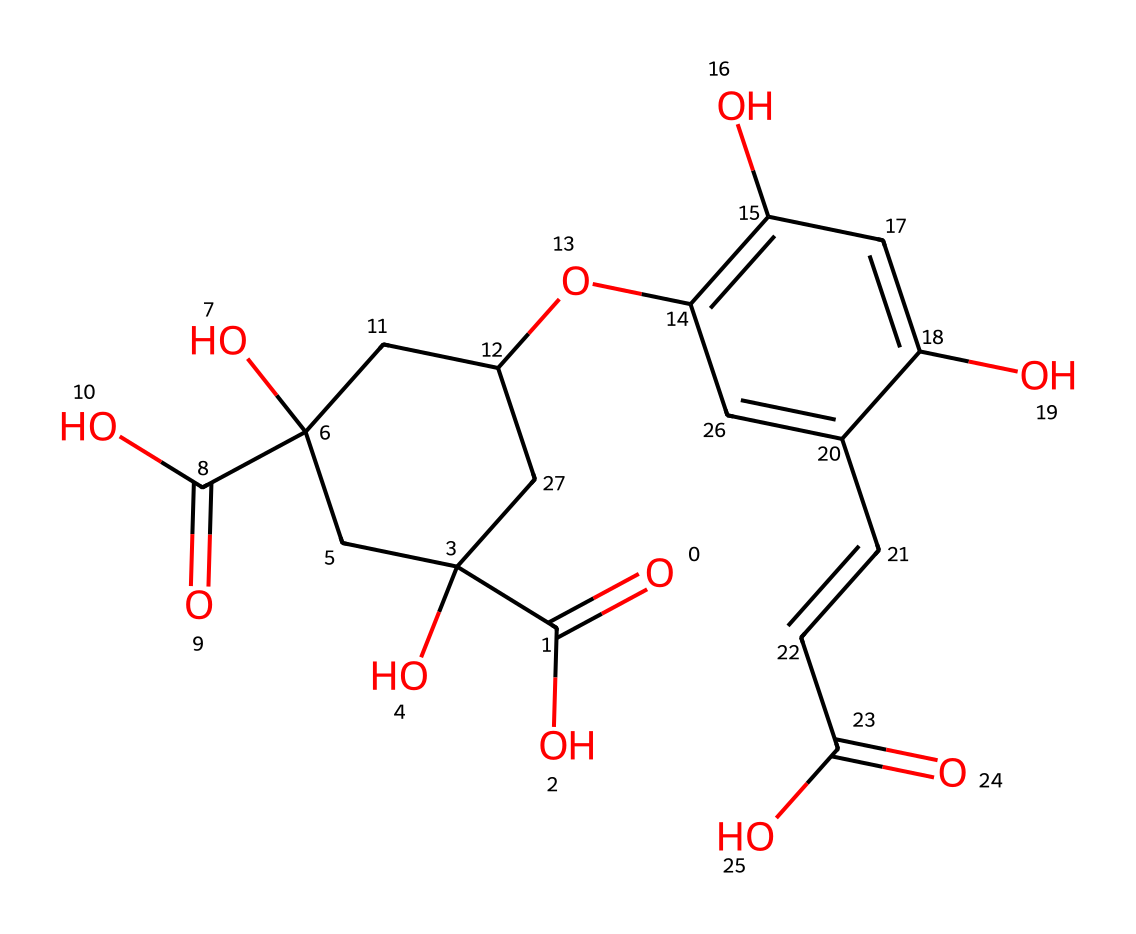What is the main functional group present in chlorogenic acid? Chlorogenic acid features multiple functional groups, the most prominent being the carboxylic acid groups (as indicated by the -COOH symbols in the structure).
Answer: carboxylic acid How many carbon atoms are in chlorogenic acid? By counting the carbon atoms represented in the SMILES format, there are 17 carbon atoms in total.
Answer: 17 What type of molecular structure does chlorogenic acid possess? The presence of multiple ring structures and hydroxyl groups indicates that chlorogenic acid has a polyphenolic structure.
Answer: polyphenolic How many hydroxyl groups are present in chlorogenic acid? Examination of the SMILES shows multiple -OH (hydroxyl) groups; specifically, there are 5 hydroxyl groups in the structure.
Answer: 5 What is the significance of the double bonds in chlorogenic acid? The presence of double bonds (indicated by the '=' signs) contributes to the antioxidant properties of chlorogenic acid, allowing it to scavenge free radicals effectively.
Answer: antioxidant properties 